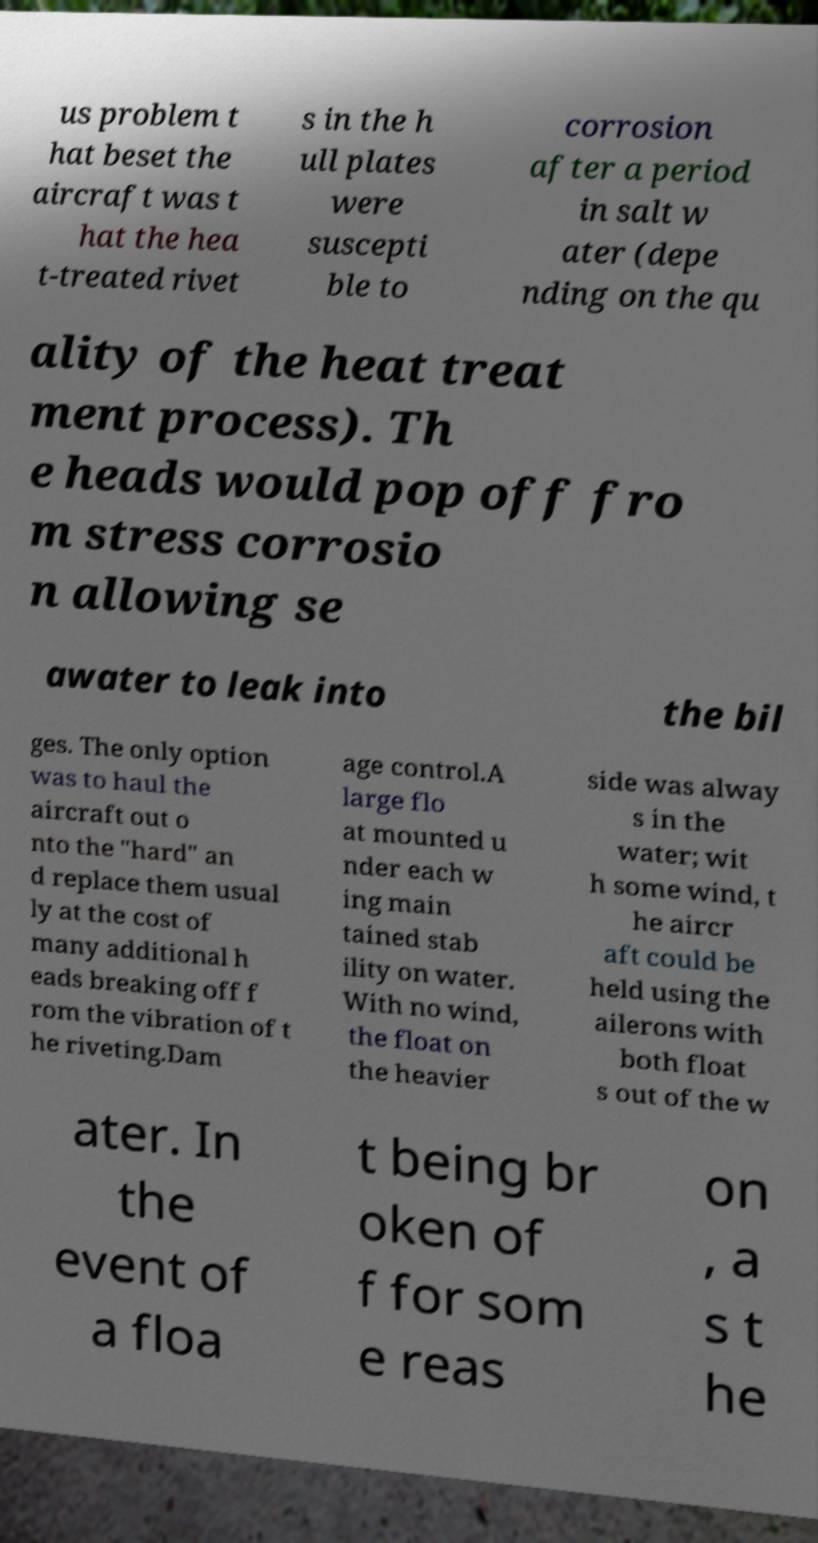There's text embedded in this image that I need extracted. Can you transcribe it verbatim? us problem t hat beset the aircraft was t hat the hea t-treated rivet s in the h ull plates were suscepti ble to corrosion after a period in salt w ater (depe nding on the qu ality of the heat treat ment process). Th e heads would pop off fro m stress corrosio n allowing se awater to leak into the bil ges. The only option was to haul the aircraft out o nto the "hard" an d replace them usual ly at the cost of many additional h eads breaking off f rom the vibration of t he riveting.Dam age control.A large flo at mounted u nder each w ing main tained stab ility on water. With no wind, the float on the heavier side was alway s in the water; wit h some wind, t he aircr aft could be held using the ailerons with both float s out of the w ater. In the event of a floa t being br oken of f for som e reas on , a s t he 